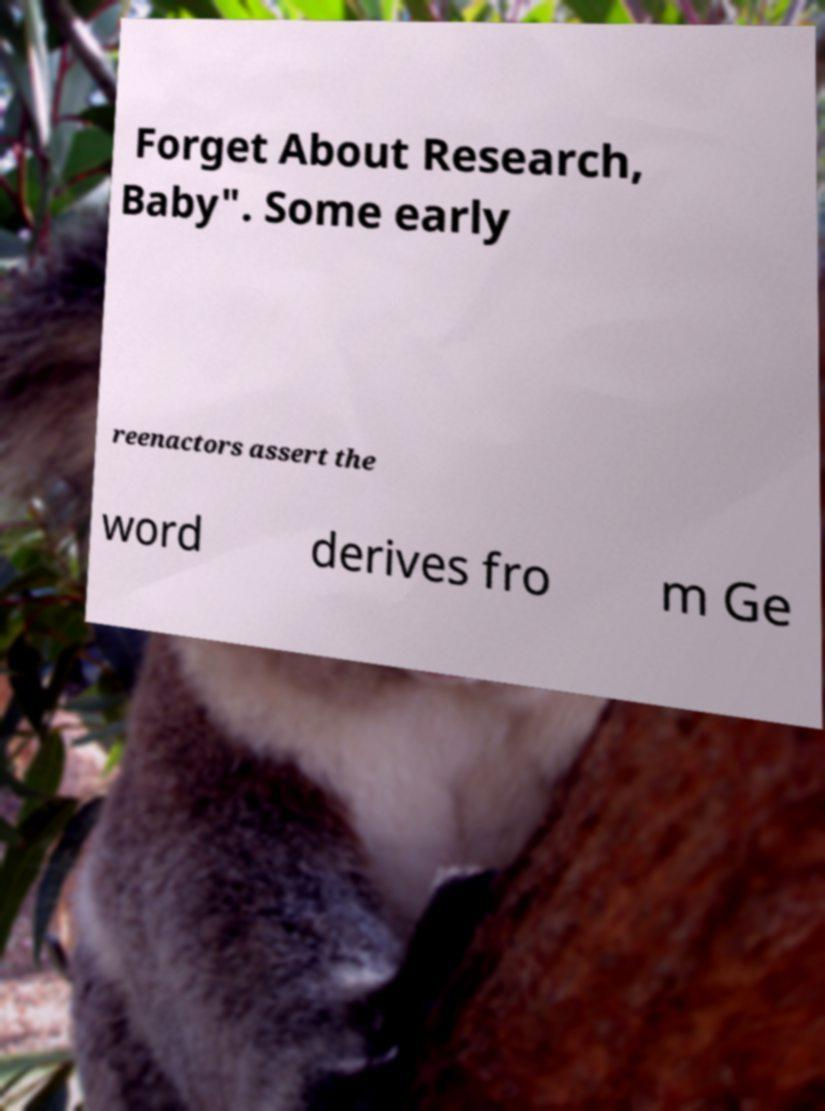There's text embedded in this image that I need extracted. Can you transcribe it verbatim? Forget About Research, Baby". Some early reenactors assert the word derives fro m Ge 